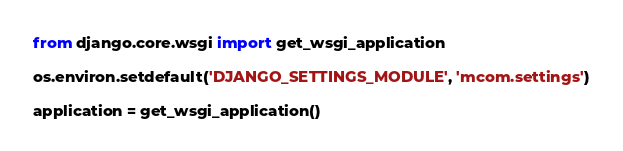Convert code to text. <code><loc_0><loc_0><loc_500><loc_500><_Python_>
from django.core.wsgi import get_wsgi_application

os.environ.setdefault('DJANGO_SETTINGS_MODULE', 'mcom.settings')

application = get_wsgi_application()
</code> 